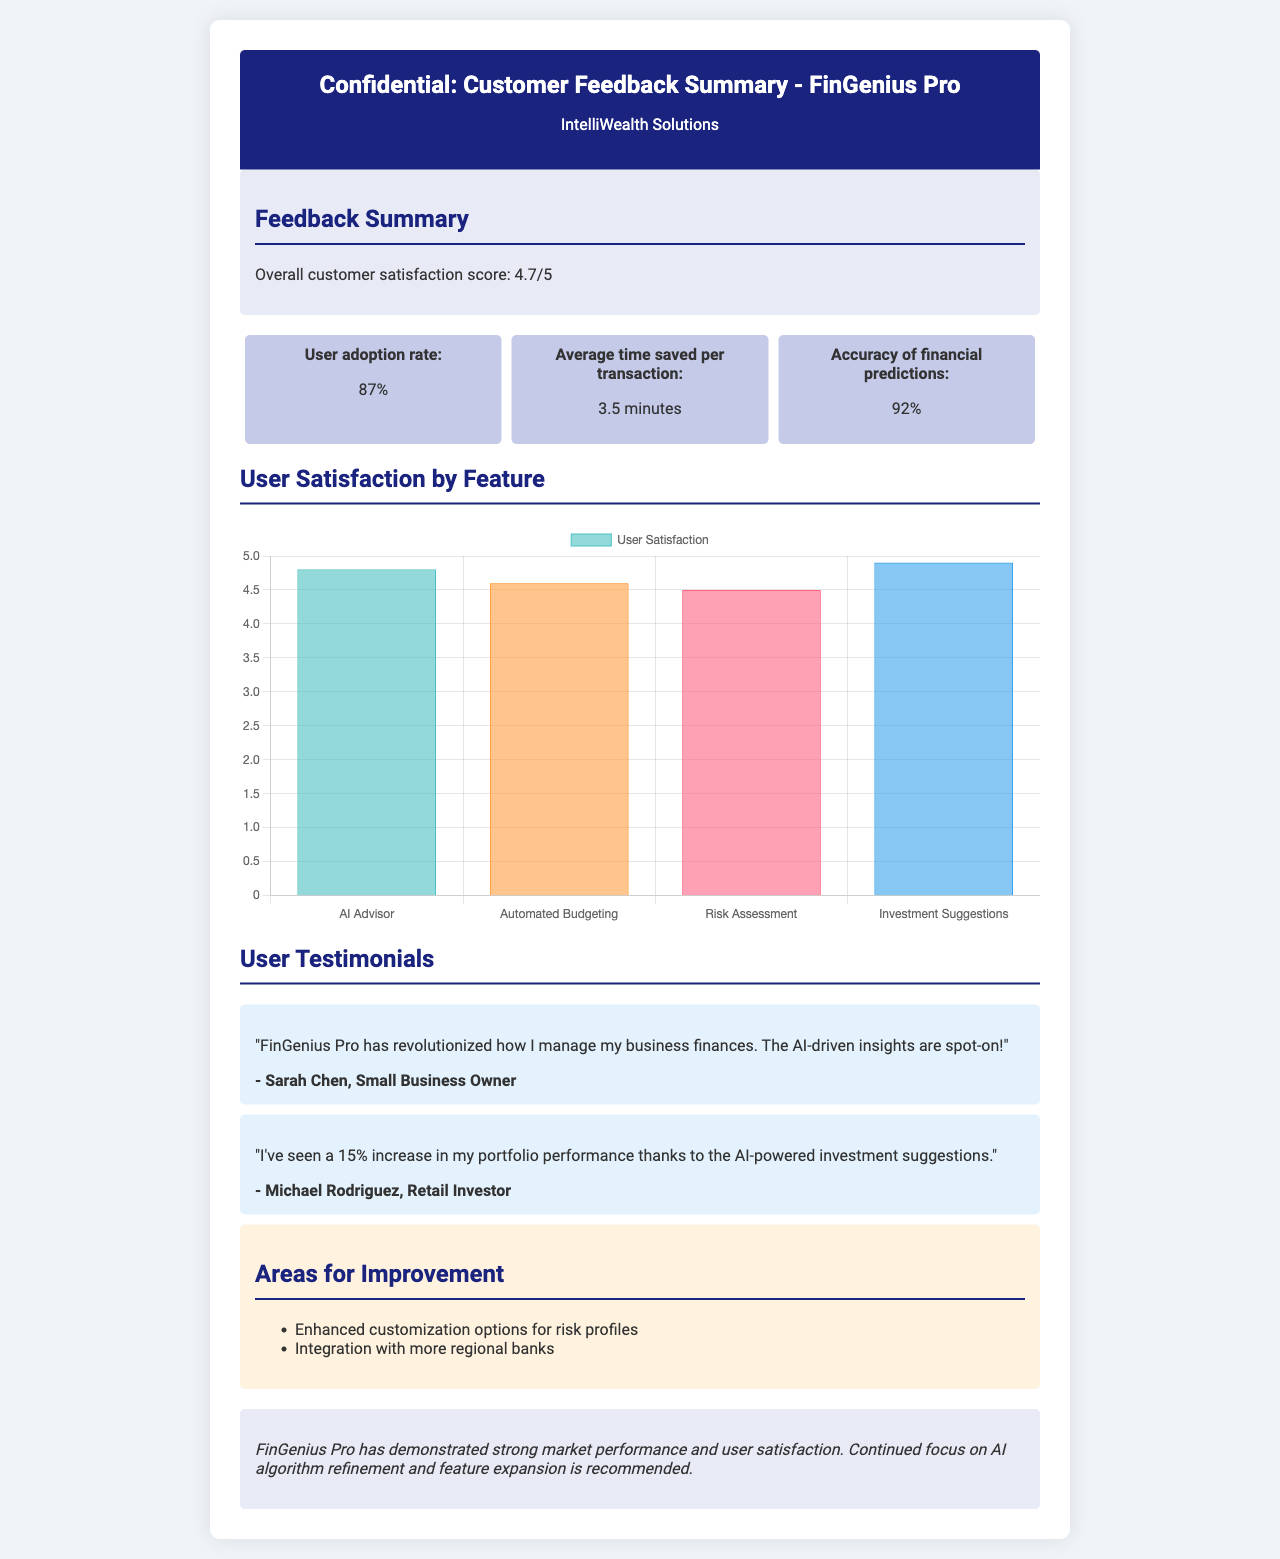What is the overall customer satisfaction score? The overall customer satisfaction score is a metric provided in the summary section of the document.
Answer: 4.7/5 What percentage of users adopted the product? The user adoption rate is a specific metric presented in the metrics section of the document.
Answer: 87% What is the average time saved per transaction? This information is located in the metrics section, specifying the average time customers save when using the product.
Answer: 3.5 minutes Which feature has the highest user satisfaction? User satisfaction ratings by feature are shown in the satisfaction chart; the highest rating corresponds to a specific feature.
Answer: AI Advisor What are two areas mentioned for improvement? The document lists areas for improvement in a dedicated section, which highlights specific customer feedback.
Answer: Enhanced customization options for risk profiles, Integration with more regional banks Who is a testimonial from? The document includes user testimonials that reference specific individuals and their feedback about the product.
Answer: Sarah Chen What is the accuracy of financial predictions? The accuracy of financial predictions is a critical metric provided among the metrics.
Answer: 92% What is the recommendation from the conclusion? The conclusion section of the document provides a recommendation based on the feedback summary.
Answer: Continued focus on AI algorithm refinement and feature expansion 